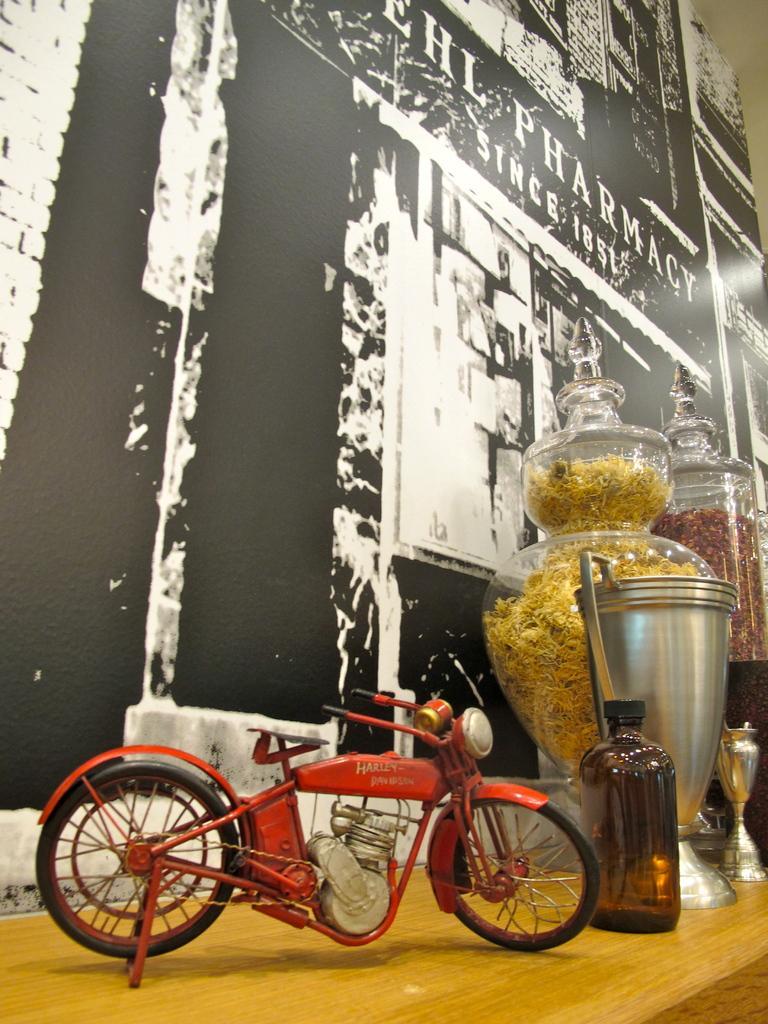Describe this image in one or two sentences. In this image there is a table, on that table there are jars, in that jars there is a food item and a toy bike, in the background there is a wall. 